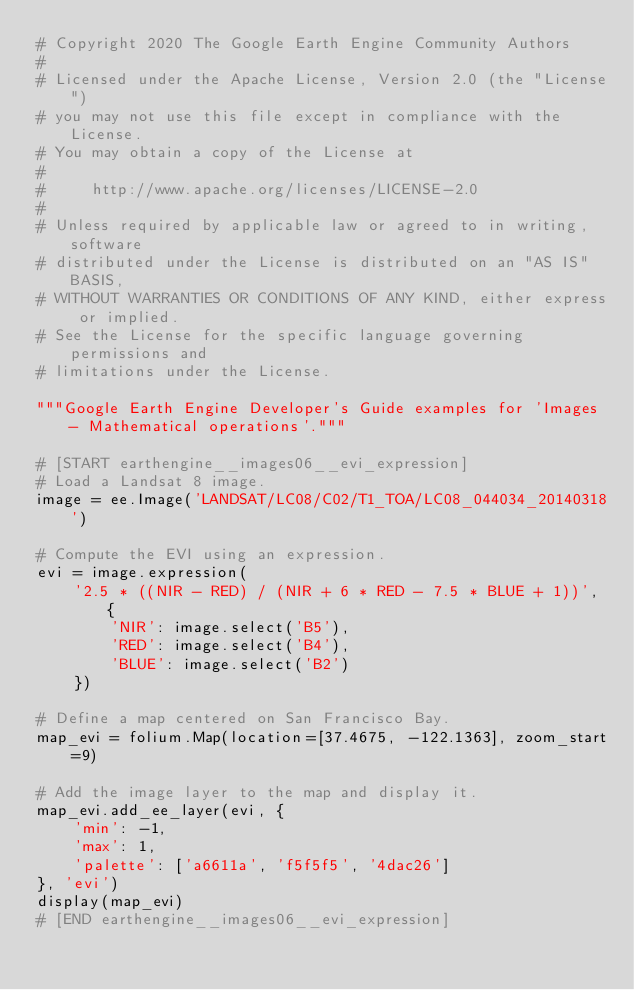<code> <loc_0><loc_0><loc_500><loc_500><_Python_># Copyright 2020 The Google Earth Engine Community Authors
#
# Licensed under the Apache License, Version 2.0 (the "License")
# you may not use this file except in compliance with the License.
# You may obtain a copy of the License at
#
#     http://www.apache.org/licenses/LICENSE-2.0
#
# Unless required by applicable law or agreed to in writing, software
# distributed under the License is distributed on an "AS IS" BASIS,
# WITHOUT WARRANTIES OR CONDITIONS OF ANY KIND, either express or implied.
# See the License for the specific language governing permissions and
# limitations under the License.

"""Google Earth Engine Developer's Guide examples for 'Images - Mathematical operations'."""

# [START earthengine__images06__evi_expression]
# Load a Landsat 8 image.
image = ee.Image('LANDSAT/LC08/C02/T1_TOA/LC08_044034_20140318')

# Compute the EVI using an expression.
evi = image.expression(
    '2.5 * ((NIR - RED) / (NIR + 6 * RED - 7.5 * BLUE + 1))', {
        'NIR': image.select('B5'),
        'RED': image.select('B4'),
        'BLUE': image.select('B2')
    })

# Define a map centered on San Francisco Bay.
map_evi = folium.Map(location=[37.4675, -122.1363], zoom_start=9)

# Add the image layer to the map and display it.
map_evi.add_ee_layer(evi, {
    'min': -1,
    'max': 1,
    'palette': ['a6611a', 'f5f5f5', '4dac26']
}, 'evi')
display(map_evi)
# [END earthengine__images06__evi_expression]
</code> 